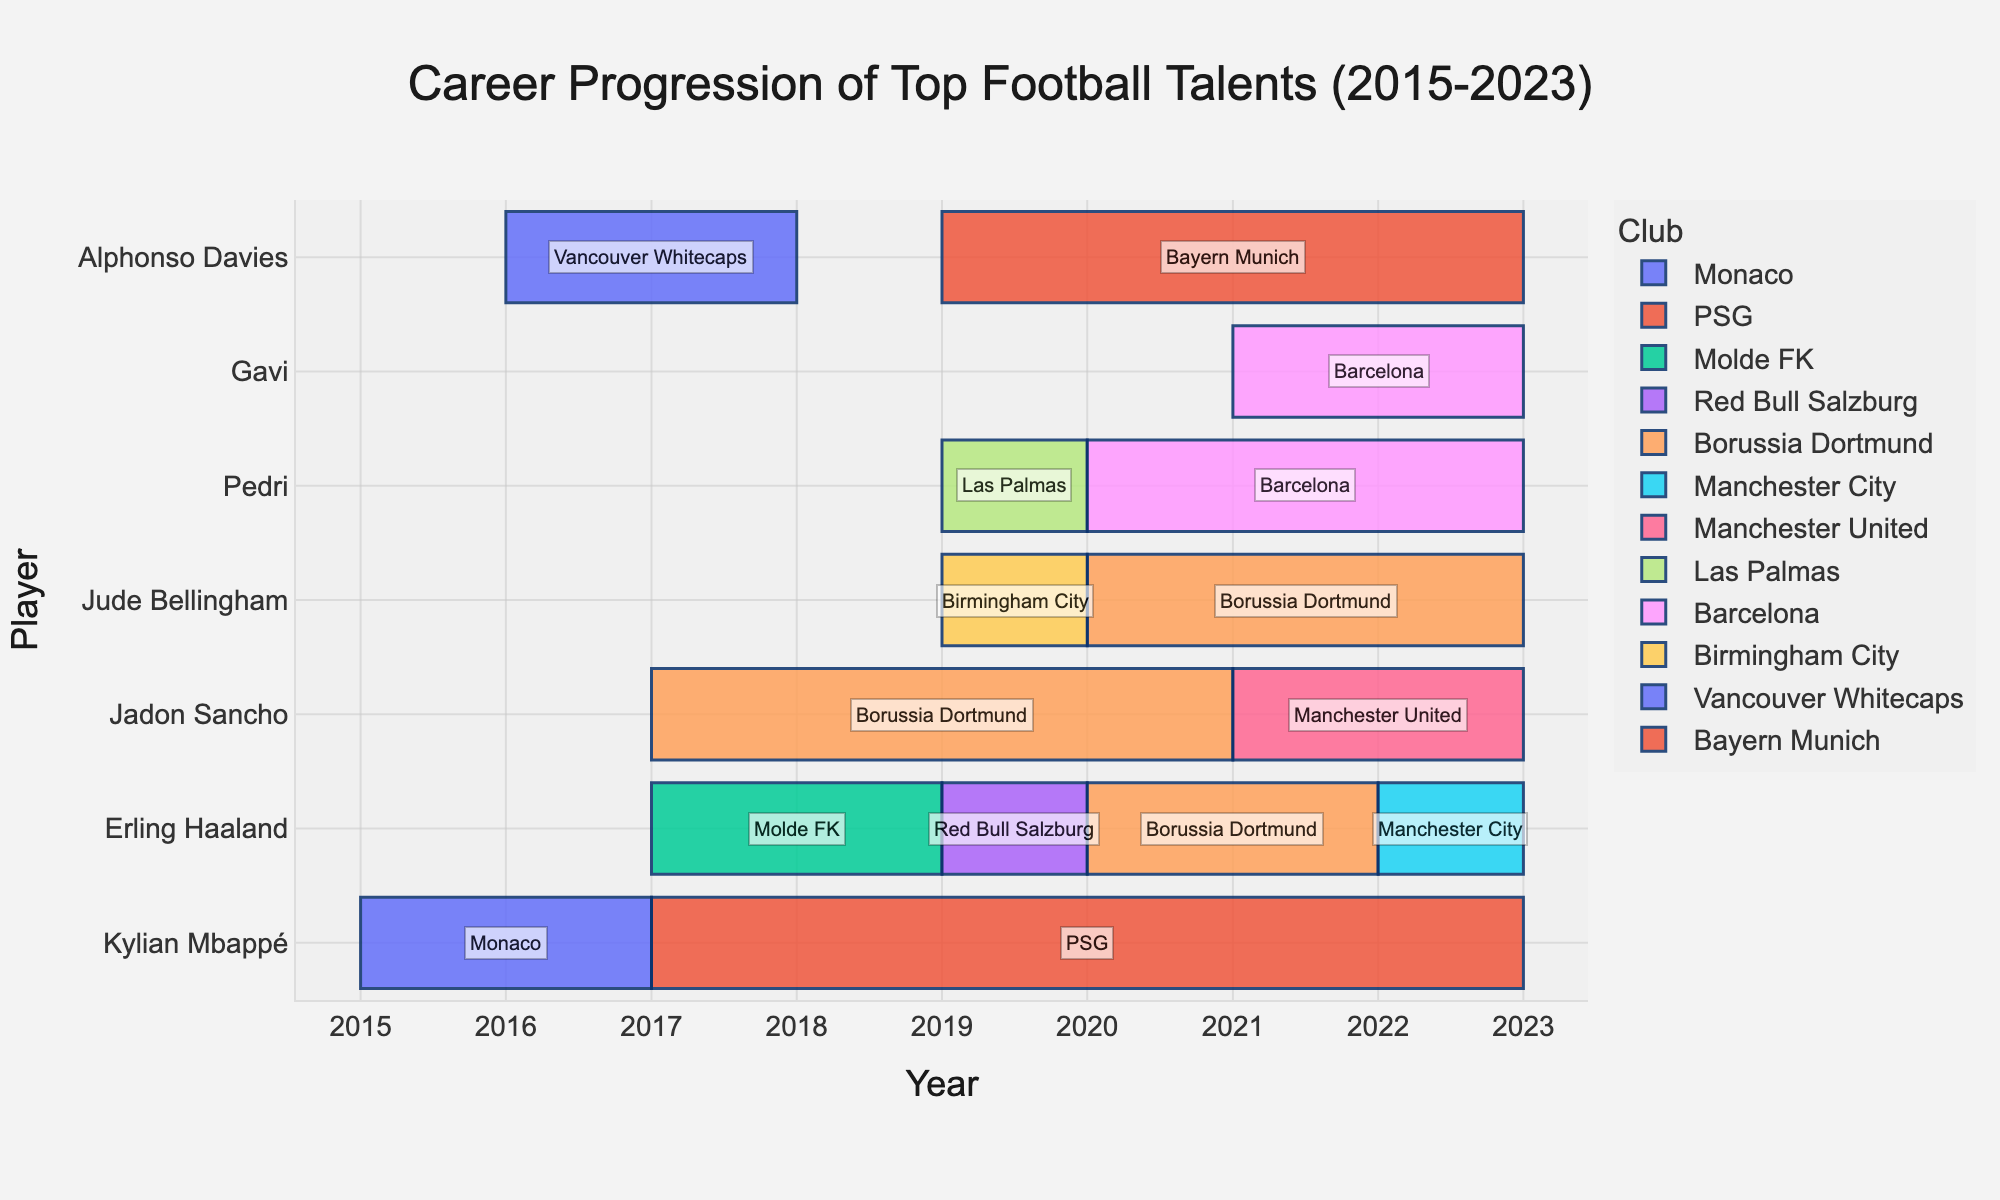what's the title of the chart? The title is usually displayed at the top of the figure. In this case, the title "Career Progression of Top Football Talents (2015-2023)" is explicitly mentioned in the setup of the figure layout.
Answer: Career Progression of Top Football Talents (2015-2023) Which player has been with their current club the longest? To find this, you need to identify the player with the longest "End" year relative to their most recent "Start" year among all players. Kylian Mbappé joined PSG in 2017 and his timeline continues till 2023, making it 6 years.
Answer: Kylian Mbappé How many clubs did Erling Haaland play for from 2017 to 2023? You need to count the number of entries for Erling Haaland within this period. According to the data, Erling Haaland played for Molde FK, Red Bull Salzburg, Borussia Dortmund, and Manchester City.
Answer: 4 Which players started their professional careers in 2019? You need to look at the "Start" year for each player and identify those who started in 2019: Pedri and Jude Bellingham.
Answer: Pedri and Jude Bellingham Compare the careers of Jadon Sancho and Jude Bellingham in terms of the number of years spent at Borussia Dortmund. First, determine the duration each player spent at Borussia Dortmund. Jadon Sancho: 2017-2021 (4 years); Jude Bellingham: 2020-2023 (3 years).
Answer: Jadon Sancho spent 1 more year at Borussia Dortmund Who played for Barcelona in this timeline? By examining the data, you can find that both Pedri and Gavi had entries showing they played for Barcelona.
Answer: Pedri and Gavi Which club has the most representation in the list? By counting the occurrences of each club in the "Position" column, Borussia Dortmund appears the most frequently, with entries for Jadon Sancho, Erling Haaland, and Jude Bellingham.
Answer: Borussia Dortmund For how many years did Alphonso Davies play at Vancouver Whitecaps? Alphonso Davies's tenure at Vancouver Whitecaps is from 2016 to 2018. Calculate the difference: 2018 - 2016 = 2 years.
Answer: 2 years Which player had the shortest stint at a single club, and how long was it? By identifying the shortest "End"-"Start" duration from the data, Erling Haaland played for Red Bull Salzburg from 2019 to 2020, which is 1 year.
Answer: Erling Haaland, 1 year 